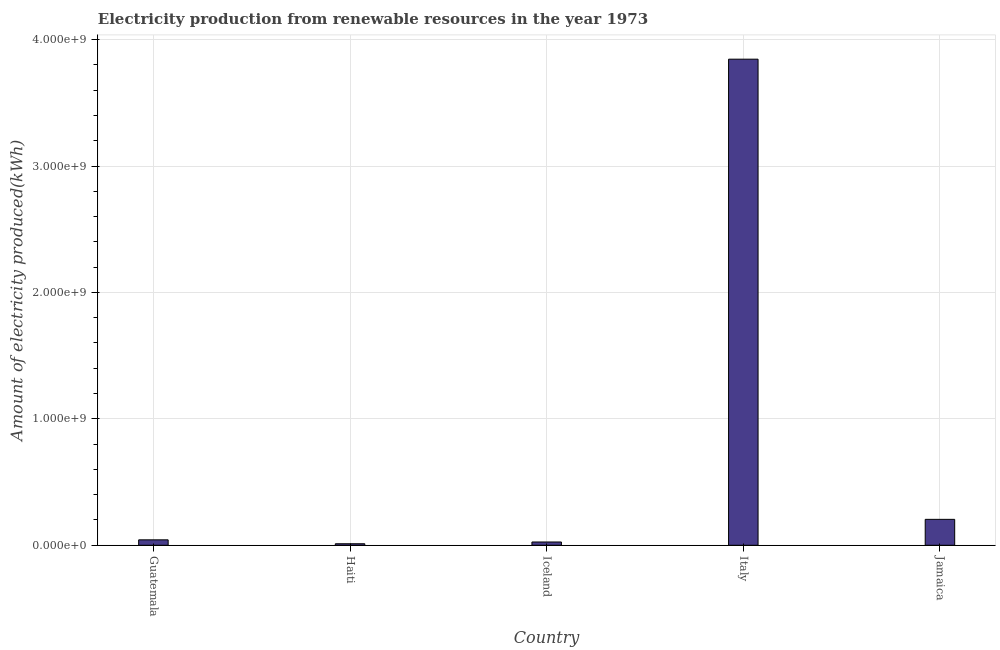What is the title of the graph?
Provide a succinct answer. Electricity production from renewable resources in the year 1973. What is the label or title of the X-axis?
Your answer should be very brief. Country. What is the label or title of the Y-axis?
Offer a terse response. Amount of electricity produced(kWh). What is the amount of electricity produced in Italy?
Provide a succinct answer. 3.84e+09. Across all countries, what is the maximum amount of electricity produced?
Your response must be concise. 3.84e+09. In which country was the amount of electricity produced minimum?
Make the answer very short. Haiti. What is the sum of the amount of electricity produced?
Your answer should be very brief. 4.13e+09. What is the difference between the amount of electricity produced in Guatemala and Jamaica?
Your response must be concise. -1.62e+08. What is the average amount of electricity produced per country?
Give a very brief answer. 8.26e+08. What is the median amount of electricity produced?
Your answer should be very brief. 4.30e+07. What is the ratio of the amount of electricity produced in Italy to that in Jamaica?
Provide a succinct answer. 18.76. Is the amount of electricity produced in Italy less than that in Jamaica?
Provide a short and direct response. No. What is the difference between the highest and the second highest amount of electricity produced?
Your response must be concise. 3.64e+09. Is the sum of the amount of electricity produced in Haiti and Iceland greater than the maximum amount of electricity produced across all countries?
Your answer should be very brief. No. What is the difference between the highest and the lowest amount of electricity produced?
Offer a very short reply. 3.83e+09. In how many countries, is the amount of electricity produced greater than the average amount of electricity produced taken over all countries?
Keep it short and to the point. 1. Are all the bars in the graph horizontal?
Offer a very short reply. No. How many countries are there in the graph?
Offer a very short reply. 5. What is the difference between two consecutive major ticks on the Y-axis?
Provide a short and direct response. 1.00e+09. Are the values on the major ticks of Y-axis written in scientific E-notation?
Your answer should be very brief. Yes. What is the Amount of electricity produced(kWh) of Guatemala?
Your response must be concise. 4.30e+07. What is the Amount of electricity produced(kWh) in Haiti?
Ensure brevity in your answer.  1.20e+07. What is the Amount of electricity produced(kWh) of Iceland?
Your response must be concise. 2.60e+07. What is the Amount of electricity produced(kWh) of Italy?
Provide a succinct answer. 3.84e+09. What is the Amount of electricity produced(kWh) in Jamaica?
Provide a short and direct response. 2.05e+08. What is the difference between the Amount of electricity produced(kWh) in Guatemala and Haiti?
Ensure brevity in your answer.  3.10e+07. What is the difference between the Amount of electricity produced(kWh) in Guatemala and Iceland?
Offer a very short reply. 1.70e+07. What is the difference between the Amount of electricity produced(kWh) in Guatemala and Italy?
Make the answer very short. -3.80e+09. What is the difference between the Amount of electricity produced(kWh) in Guatemala and Jamaica?
Your response must be concise. -1.62e+08. What is the difference between the Amount of electricity produced(kWh) in Haiti and Iceland?
Provide a succinct answer. -1.40e+07. What is the difference between the Amount of electricity produced(kWh) in Haiti and Italy?
Offer a terse response. -3.83e+09. What is the difference between the Amount of electricity produced(kWh) in Haiti and Jamaica?
Your answer should be very brief. -1.93e+08. What is the difference between the Amount of electricity produced(kWh) in Iceland and Italy?
Offer a very short reply. -3.82e+09. What is the difference between the Amount of electricity produced(kWh) in Iceland and Jamaica?
Ensure brevity in your answer.  -1.79e+08. What is the difference between the Amount of electricity produced(kWh) in Italy and Jamaica?
Ensure brevity in your answer.  3.64e+09. What is the ratio of the Amount of electricity produced(kWh) in Guatemala to that in Haiti?
Offer a very short reply. 3.58. What is the ratio of the Amount of electricity produced(kWh) in Guatemala to that in Iceland?
Give a very brief answer. 1.65. What is the ratio of the Amount of electricity produced(kWh) in Guatemala to that in Italy?
Provide a succinct answer. 0.01. What is the ratio of the Amount of electricity produced(kWh) in Guatemala to that in Jamaica?
Offer a terse response. 0.21. What is the ratio of the Amount of electricity produced(kWh) in Haiti to that in Iceland?
Give a very brief answer. 0.46. What is the ratio of the Amount of electricity produced(kWh) in Haiti to that in Italy?
Ensure brevity in your answer.  0. What is the ratio of the Amount of electricity produced(kWh) in Haiti to that in Jamaica?
Your response must be concise. 0.06. What is the ratio of the Amount of electricity produced(kWh) in Iceland to that in Italy?
Make the answer very short. 0.01. What is the ratio of the Amount of electricity produced(kWh) in Iceland to that in Jamaica?
Keep it short and to the point. 0.13. What is the ratio of the Amount of electricity produced(kWh) in Italy to that in Jamaica?
Your answer should be very brief. 18.76. 